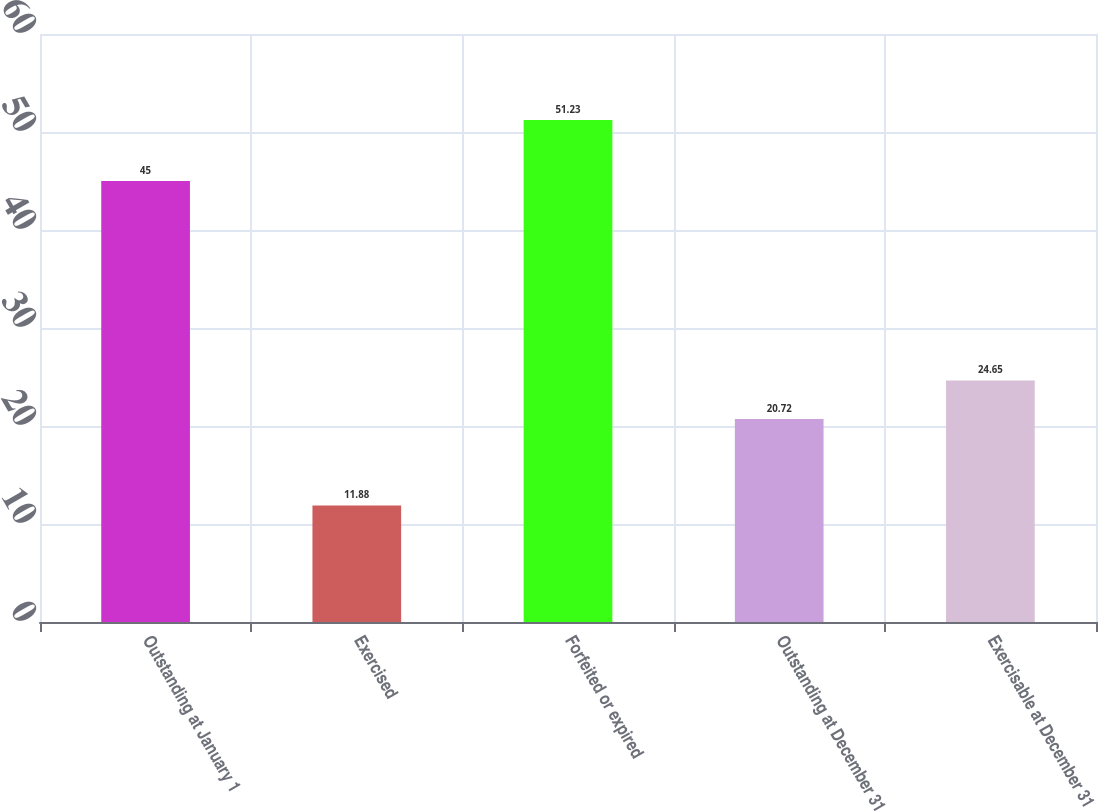Convert chart. <chart><loc_0><loc_0><loc_500><loc_500><bar_chart><fcel>Outstanding at January 1<fcel>Exercised<fcel>Forfeited or expired<fcel>Outstanding at December 31<fcel>Exercisable at December 31<nl><fcel>45<fcel>11.88<fcel>51.23<fcel>20.72<fcel>24.65<nl></chart> 